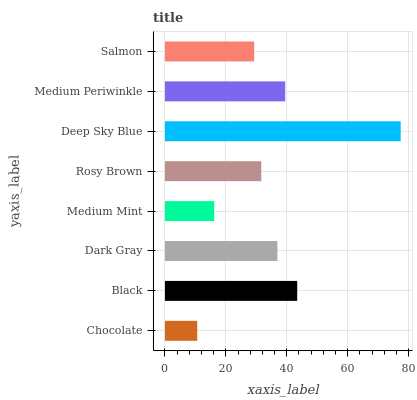Is Chocolate the minimum?
Answer yes or no. Yes. Is Deep Sky Blue the maximum?
Answer yes or no. Yes. Is Black the minimum?
Answer yes or no. No. Is Black the maximum?
Answer yes or no. No. Is Black greater than Chocolate?
Answer yes or no. Yes. Is Chocolate less than Black?
Answer yes or no. Yes. Is Chocolate greater than Black?
Answer yes or no. No. Is Black less than Chocolate?
Answer yes or no. No. Is Dark Gray the high median?
Answer yes or no. Yes. Is Rosy Brown the low median?
Answer yes or no. Yes. Is Rosy Brown the high median?
Answer yes or no. No. Is Deep Sky Blue the low median?
Answer yes or no. No. 